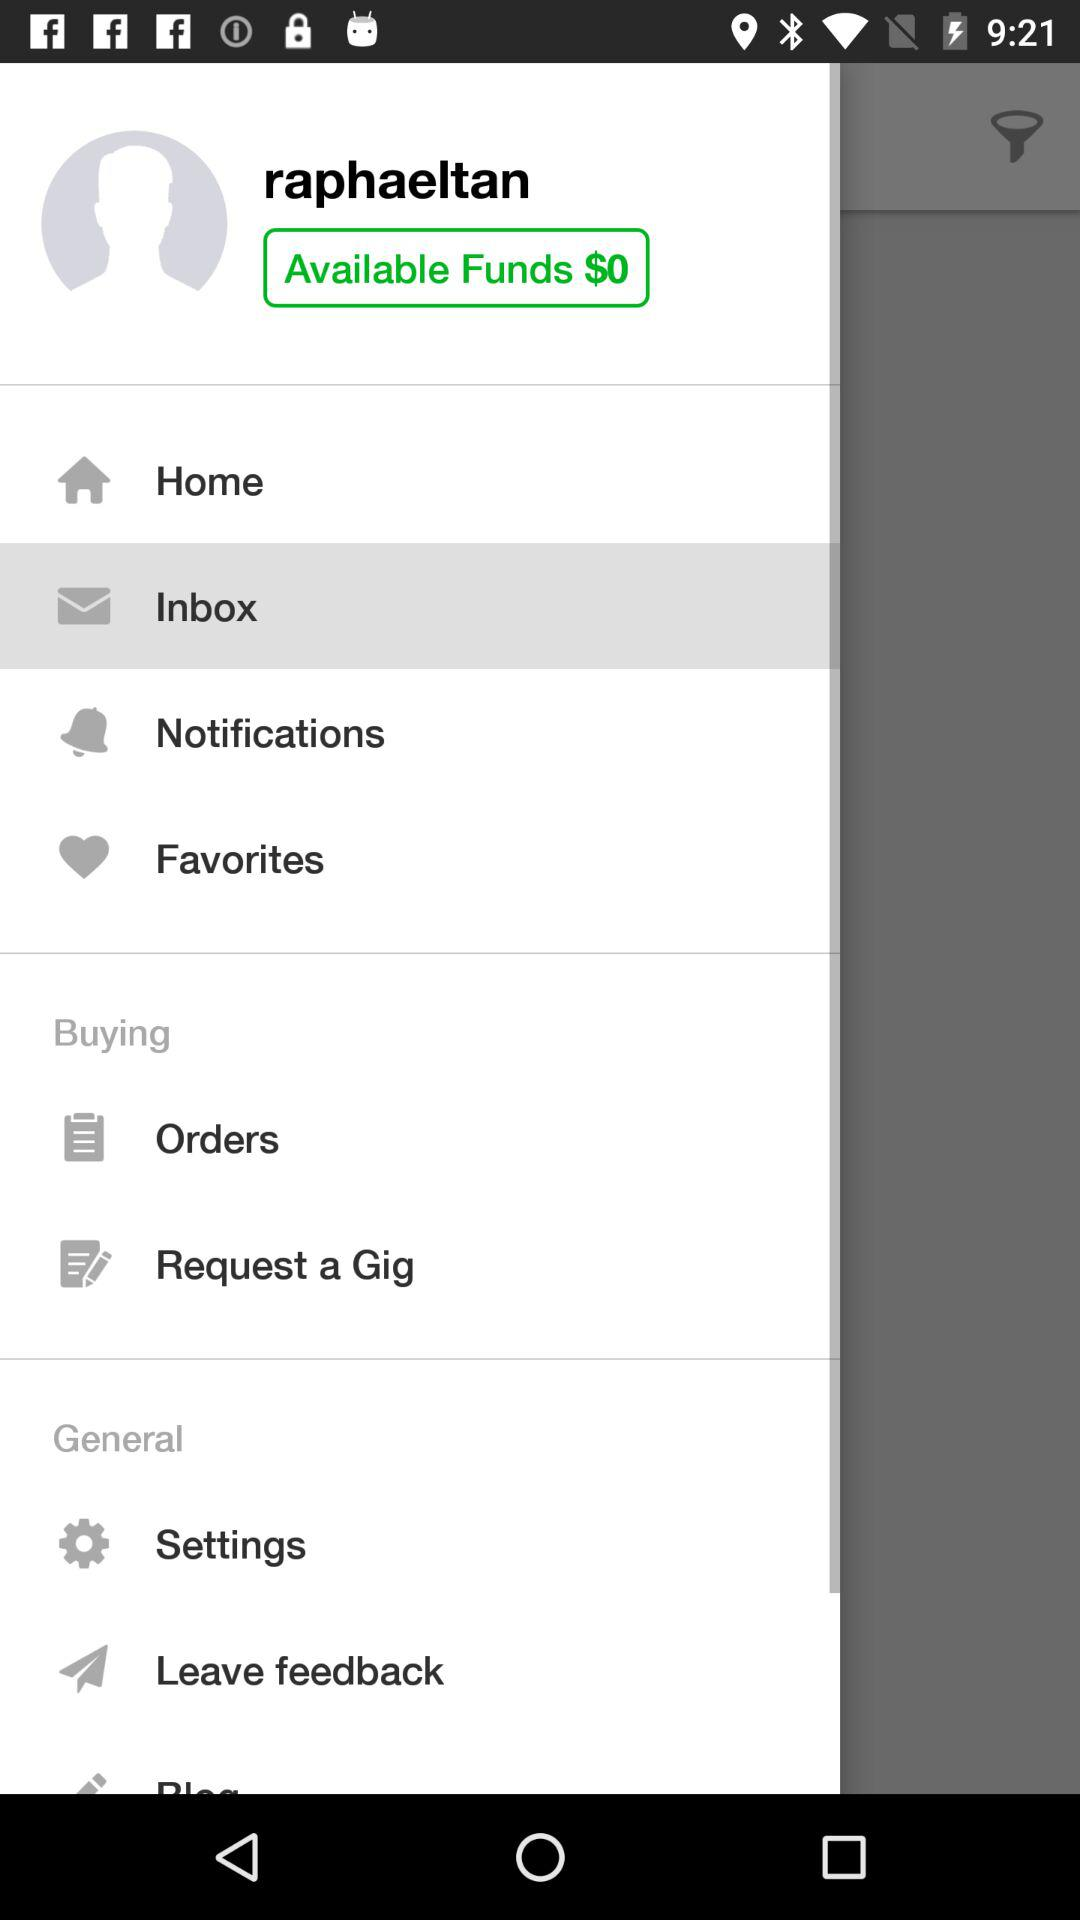What tab has been selected? The tab that has been selected is "Inbox". 